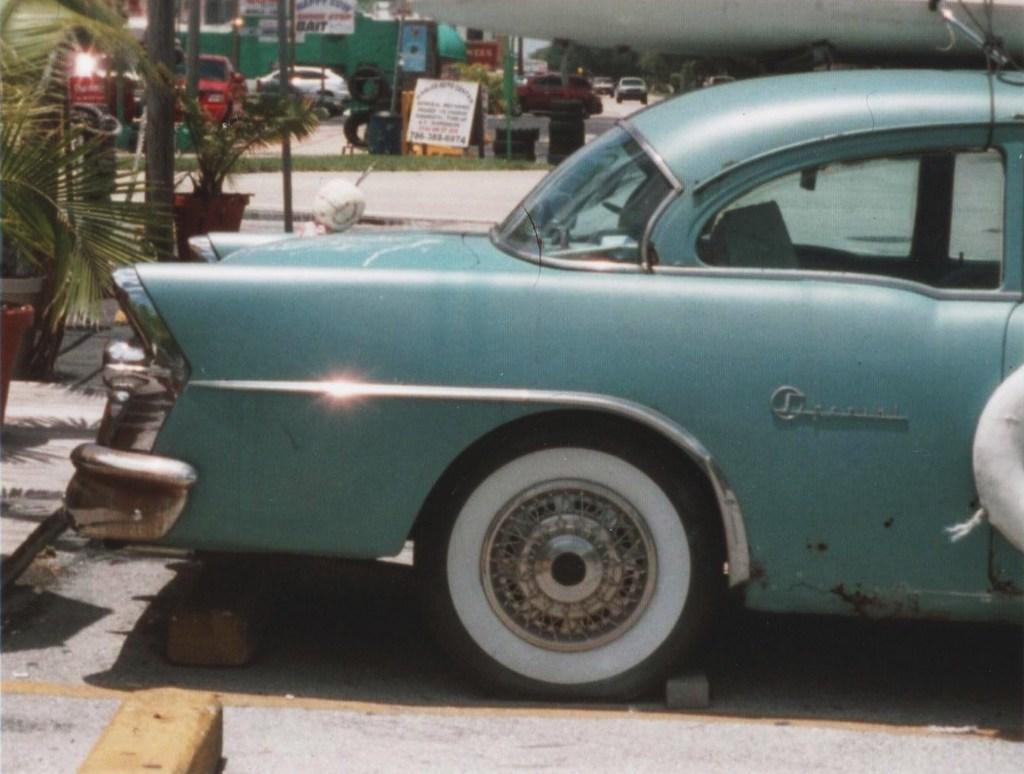In one or two sentences, can you explain what this image depicts? In the center of the image there is a car on the road. On the left side of the image we can bricks, plants, trees, pole and cars. In the background there are trees, cars and sky. 